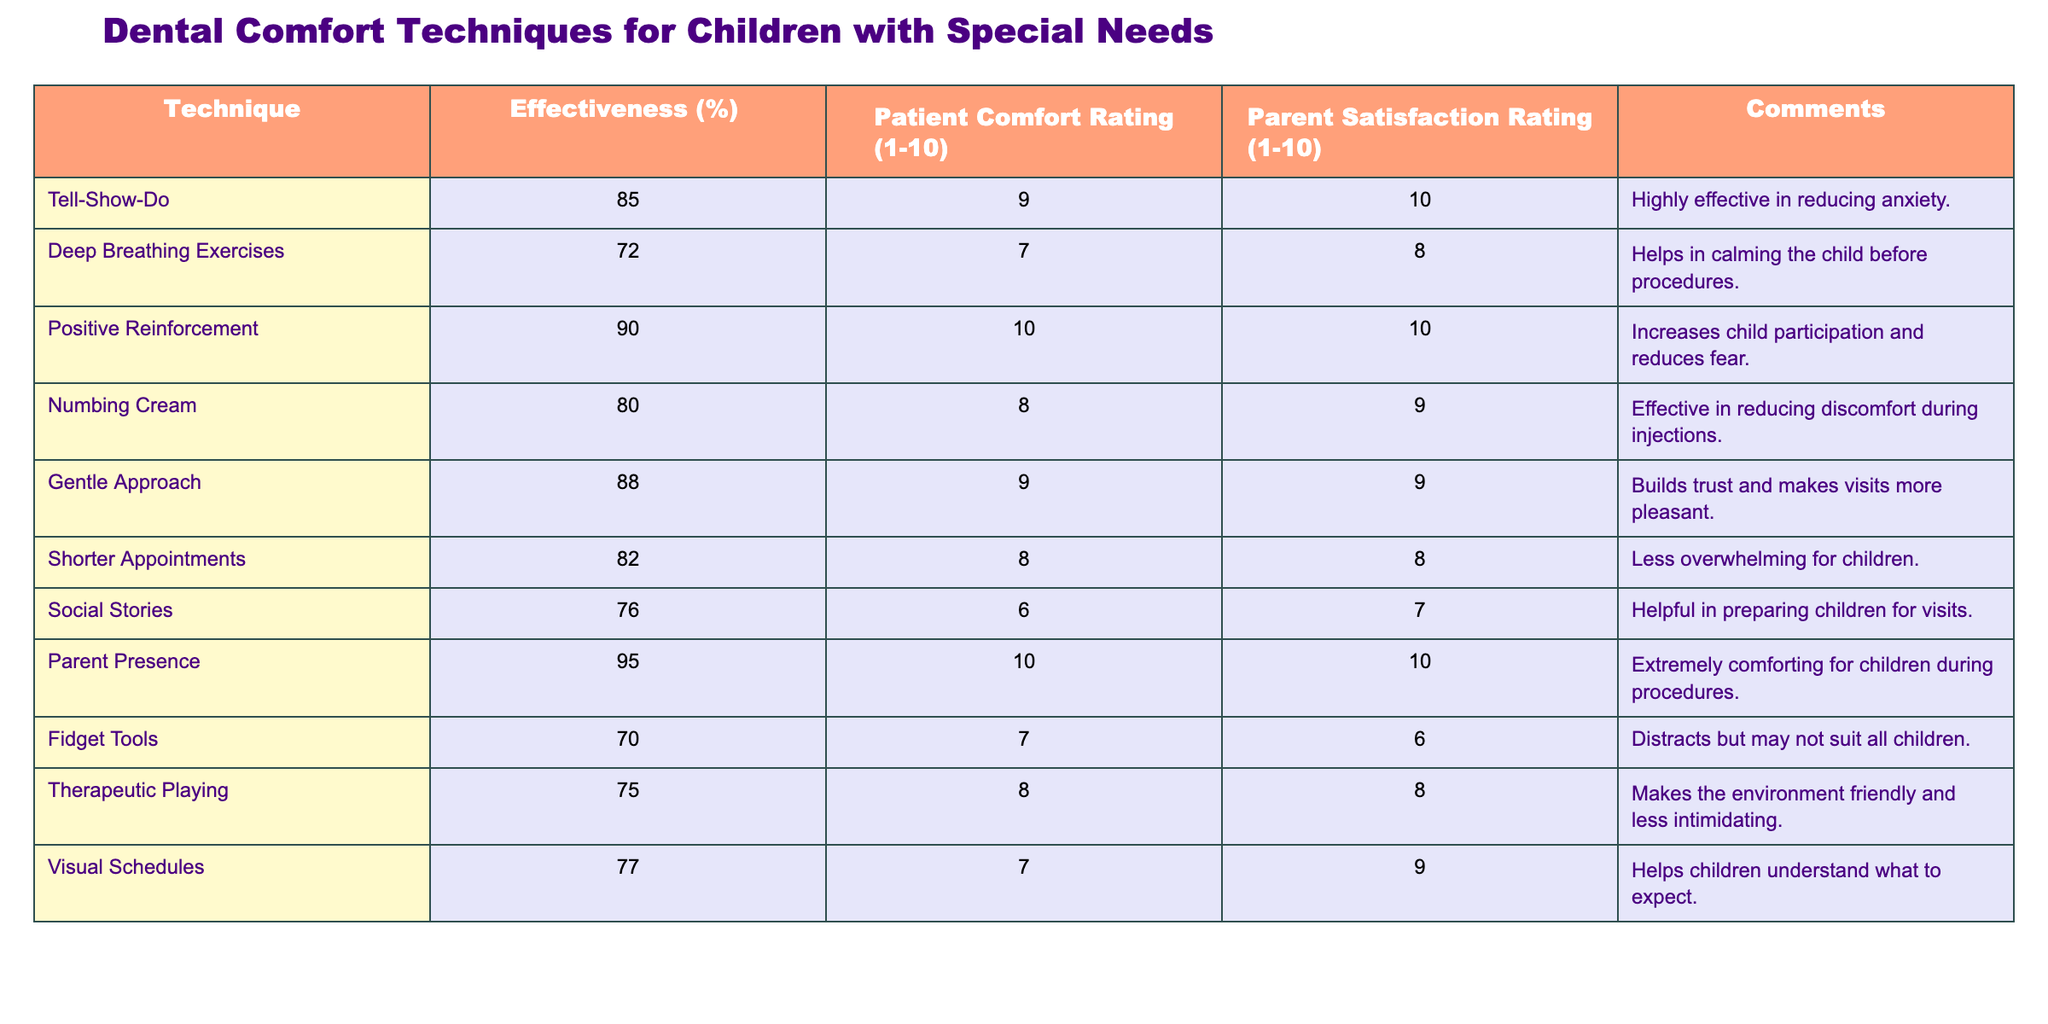What is the effectiveness percentage of Positive Reinforcement? From the table, the effectiveness percentage of Positive Reinforcement is located in the corresponding row under the "Effectiveness (%)" column and reads 90%.
Answer: 90% Which dental comfort technique received the lowest Patient Comfort Rating? By scanning the "Patient Comfort Rating (1-10)" column, the value 6 is the lowest, corresponding to the Fidget Tools technique.
Answer: Fidget Tools What is the average effectiveness percentage of the techniques listed in the table? First, we will sum the effectiveness percentages: 85 + 72 + 90 + 80 + 88 + 82 + 76 + 95 + 70 + 75 =  82.8. Next, we divide by the number of techniques, which is 10. So, 828/10 = 82.8.
Answer: 82.8 Did the Parent Satisfaction Rating for Deep Breathing Exercises exceed 7? Looking at the Parent Satisfaction Rating for Deep Breathing Exercises, it is 8, which is greater than 7. Hence, the answer is yes.
Answer: Yes What is the effectiveness percentage of techniques that include the word "short" in their description? The technique mentioned is Shorter Appointments with an effectiveness percentage of 82%. This is the only technique that includes "short."
Answer: 82% Which technique has the highest Parent Satisfaction Rating? Reviewing the "Parent Satisfaction Rating (1-10)" column, both Positive Reinforcement and Parent Presence have a rating of 10, which is the highest.
Answer: Positive Reinforcement and Parent Presence What is the difference in effectiveness percentages between the Gentle Approach and the Numbing Cream? The Gentle Approach has an effectiveness of 88% and the Numbing Cream has 80%, so we calculate the difference: 88 - 80 = 8%.
Answer: 8% Is the effectiveness percentage of Social Stories less than that of Deep Breathing Exercises? Social Stories has an effectiveness of 76%, while Deep Breathing Exercises has 72%. Since 76% is greater than 72%, the answer is no.
Answer: No What can be concluded about the techniques based on their Patient Comfort Ratings? By analyzing the Patient Comfort Ratings, we observe that techniques with higher effectiveness, like Positive Reinforcement and Parent Presence, also have the highest comfort ratings of 10, indicating a correlation between effectiveness and patient comfort.
Answer: Higher effectiveness correlates with higher comfort ratings 